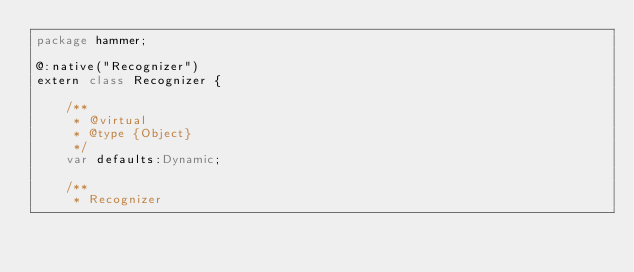<code> <loc_0><loc_0><loc_500><loc_500><_Haxe_>package hammer;

@:native("Recognizer")
extern class Recognizer {

    /**
     * @virtual
     * @type {Object}
     */
    var defaults:Dynamic;

    /**
     * Recognizer</code> 